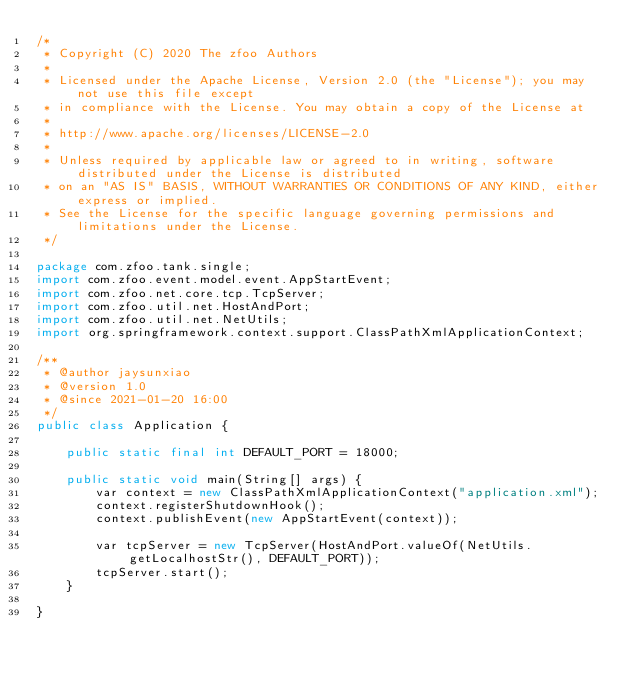Convert code to text. <code><loc_0><loc_0><loc_500><loc_500><_Java_>/*
 * Copyright (C) 2020 The zfoo Authors
 *
 * Licensed under the Apache License, Version 2.0 (the "License"); you may not use this file except
 * in compliance with the License. You may obtain a copy of the License at
 *
 * http://www.apache.org/licenses/LICENSE-2.0
 *
 * Unless required by applicable law or agreed to in writing, software distributed under the License is distributed
 * on an "AS IS" BASIS, WITHOUT WARRANTIES OR CONDITIONS OF ANY KIND, either express or implied.
 * See the License for the specific language governing permissions and limitations under the License.
 */

package com.zfoo.tank.single;
import com.zfoo.event.model.event.AppStartEvent;
import com.zfoo.net.core.tcp.TcpServer;
import com.zfoo.util.net.HostAndPort;
import com.zfoo.util.net.NetUtils;
import org.springframework.context.support.ClassPathXmlApplicationContext;

/**
 * @author jaysunxiao
 * @version 1.0
 * @since 2021-01-20 16:00
 */
public class Application {

    public static final int DEFAULT_PORT = 18000;

    public static void main(String[] args) {
        var context = new ClassPathXmlApplicationContext("application.xml");
        context.registerShutdownHook();
        context.publishEvent(new AppStartEvent(context));

        var tcpServer = new TcpServer(HostAndPort.valueOf(NetUtils.getLocalhostStr(), DEFAULT_PORT));
        tcpServer.start();
    }

}
</code> 